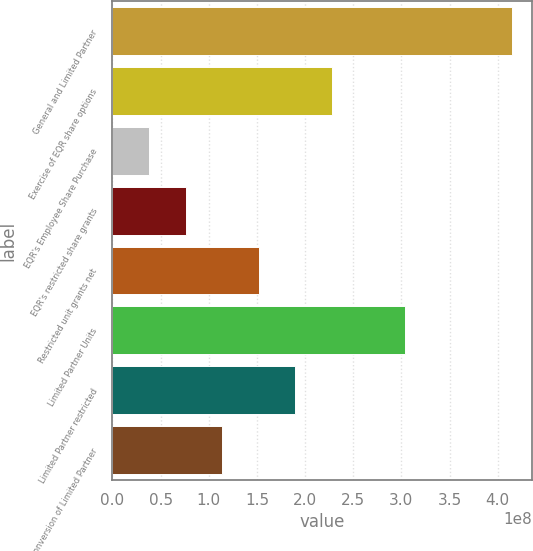Convert chart to OTSL. <chart><loc_0><loc_0><loc_500><loc_500><bar_chart><fcel>General and Limited Partner<fcel>Exercise of EQR share options<fcel>EQR's Employee Share Purchase<fcel>EQR's restricted share grants<fcel>Restricted unit grants net<fcel>Limited Partner Units<fcel>Limited Partner restricted<fcel>Conversion of Limited Partner<nl><fcel>4.15072e+08<fcel>2.2751e+08<fcel>3.79183e+07<fcel>7.58365e+07<fcel>1.51673e+08<fcel>3.03346e+08<fcel>1.89591e+08<fcel>1.13755e+08<nl></chart> 